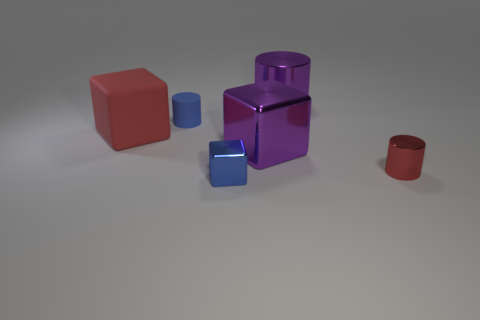Subtract all metal cubes. How many cubes are left? 1 Add 2 tiny cylinders. How many objects exist? 8 Subtract all purple blocks. How many blocks are left? 2 Subtract 2 cubes. How many cubes are left? 1 Subtract all brown cylinders. How many red blocks are left? 1 Subtract all small gray metal cubes. Subtract all tiny metallic objects. How many objects are left? 4 Add 4 purple metallic cylinders. How many purple metallic cylinders are left? 5 Add 3 blue blocks. How many blue blocks exist? 4 Subtract 0 yellow cubes. How many objects are left? 6 Subtract all green cylinders. Subtract all cyan balls. How many cylinders are left? 3 